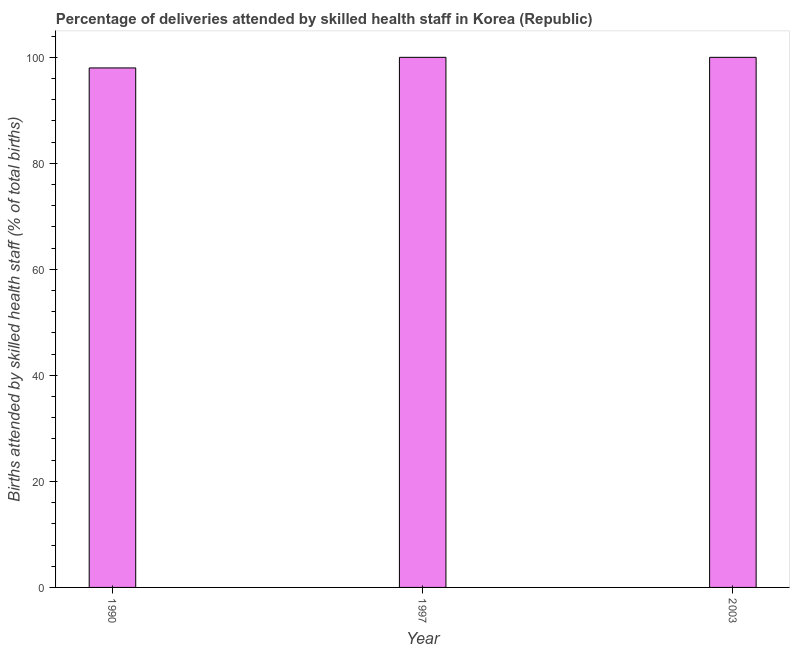Does the graph contain any zero values?
Give a very brief answer. No. Does the graph contain grids?
Keep it short and to the point. No. What is the title of the graph?
Give a very brief answer. Percentage of deliveries attended by skilled health staff in Korea (Republic). What is the label or title of the Y-axis?
Your answer should be compact. Births attended by skilled health staff (% of total births). Across all years, what is the minimum number of births attended by skilled health staff?
Your answer should be very brief. 98. In which year was the number of births attended by skilled health staff minimum?
Give a very brief answer. 1990. What is the sum of the number of births attended by skilled health staff?
Provide a succinct answer. 298. Do a majority of the years between 2003 and 1990 (inclusive) have number of births attended by skilled health staff greater than 4 %?
Provide a succinct answer. Yes. Is the number of births attended by skilled health staff in 1990 less than that in 1997?
Keep it short and to the point. Yes. What is the difference between the highest and the second highest number of births attended by skilled health staff?
Your answer should be compact. 0. In how many years, is the number of births attended by skilled health staff greater than the average number of births attended by skilled health staff taken over all years?
Provide a succinct answer. 2. Are all the bars in the graph horizontal?
Provide a succinct answer. No. How many years are there in the graph?
Ensure brevity in your answer.  3. Are the values on the major ticks of Y-axis written in scientific E-notation?
Ensure brevity in your answer.  No. What is the Births attended by skilled health staff (% of total births) of 1990?
Your response must be concise. 98. What is the Births attended by skilled health staff (% of total births) in 2003?
Your answer should be very brief. 100. What is the difference between the Births attended by skilled health staff (% of total births) in 1990 and 1997?
Offer a very short reply. -2. What is the difference between the Births attended by skilled health staff (% of total births) in 1990 and 2003?
Your response must be concise. -2. What is the difference between the Births attended by skilled health staff (% of total births) in 1997 and 2003?
Give a very brief answer. 0. What is the ratio of the Births attended by skilled health staff (% of total births) in 1997 to that in 2003?
Ensure brevity in your answer.  1. 